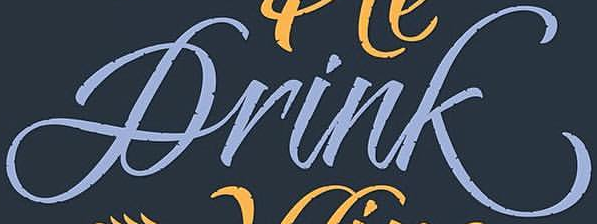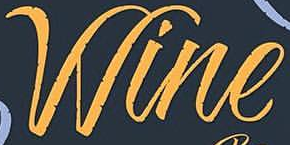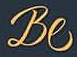What words are shown in these images in order, separated by a semicolon? Drink; Wine; Be 